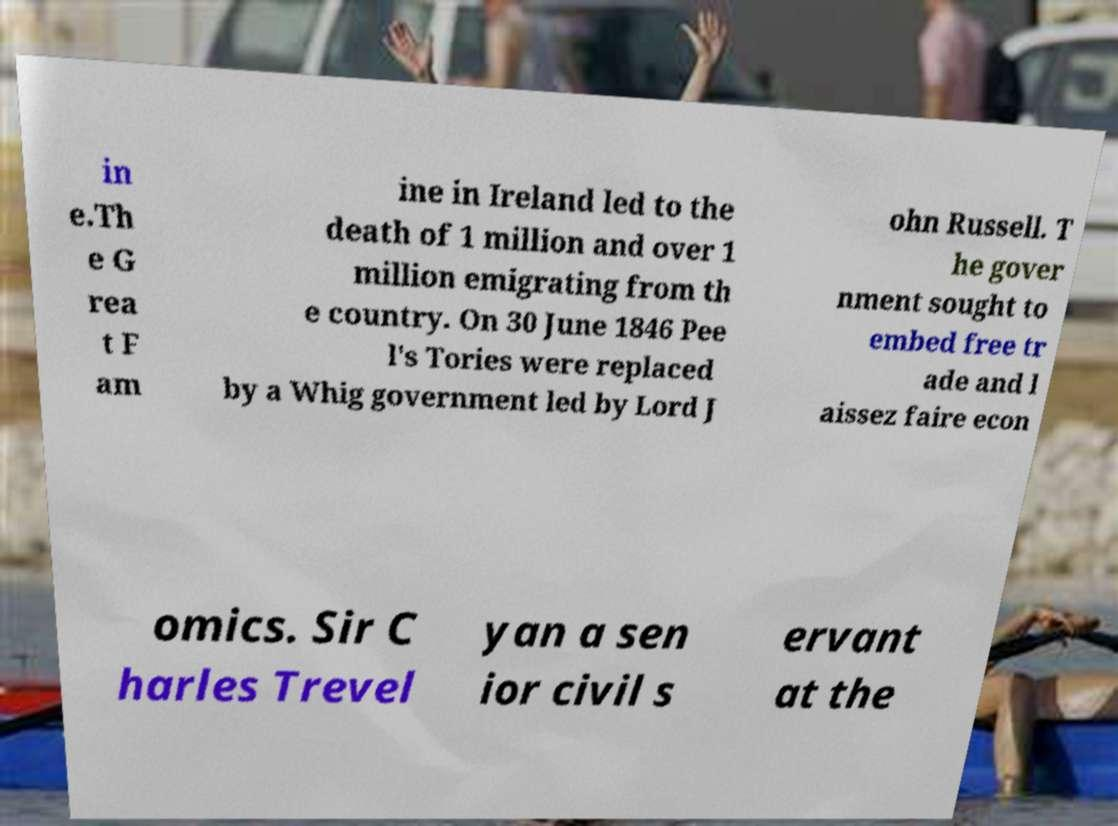For documentation purposes, I need the text within this image transcribed. Could you provide that? in e.Th e G rea t F am ine in Ireland led to the death of 1 million and over 1 million emigrating from th e country. On 30 June 1846 Pee l's Tories were replaced by a Whig government led by Lord J ohn Russell. T he gover nment sought to embed free tr ade and l aissez faire econ omics. Sir C harles Trevel yan a sen ior civil s ervant at the 